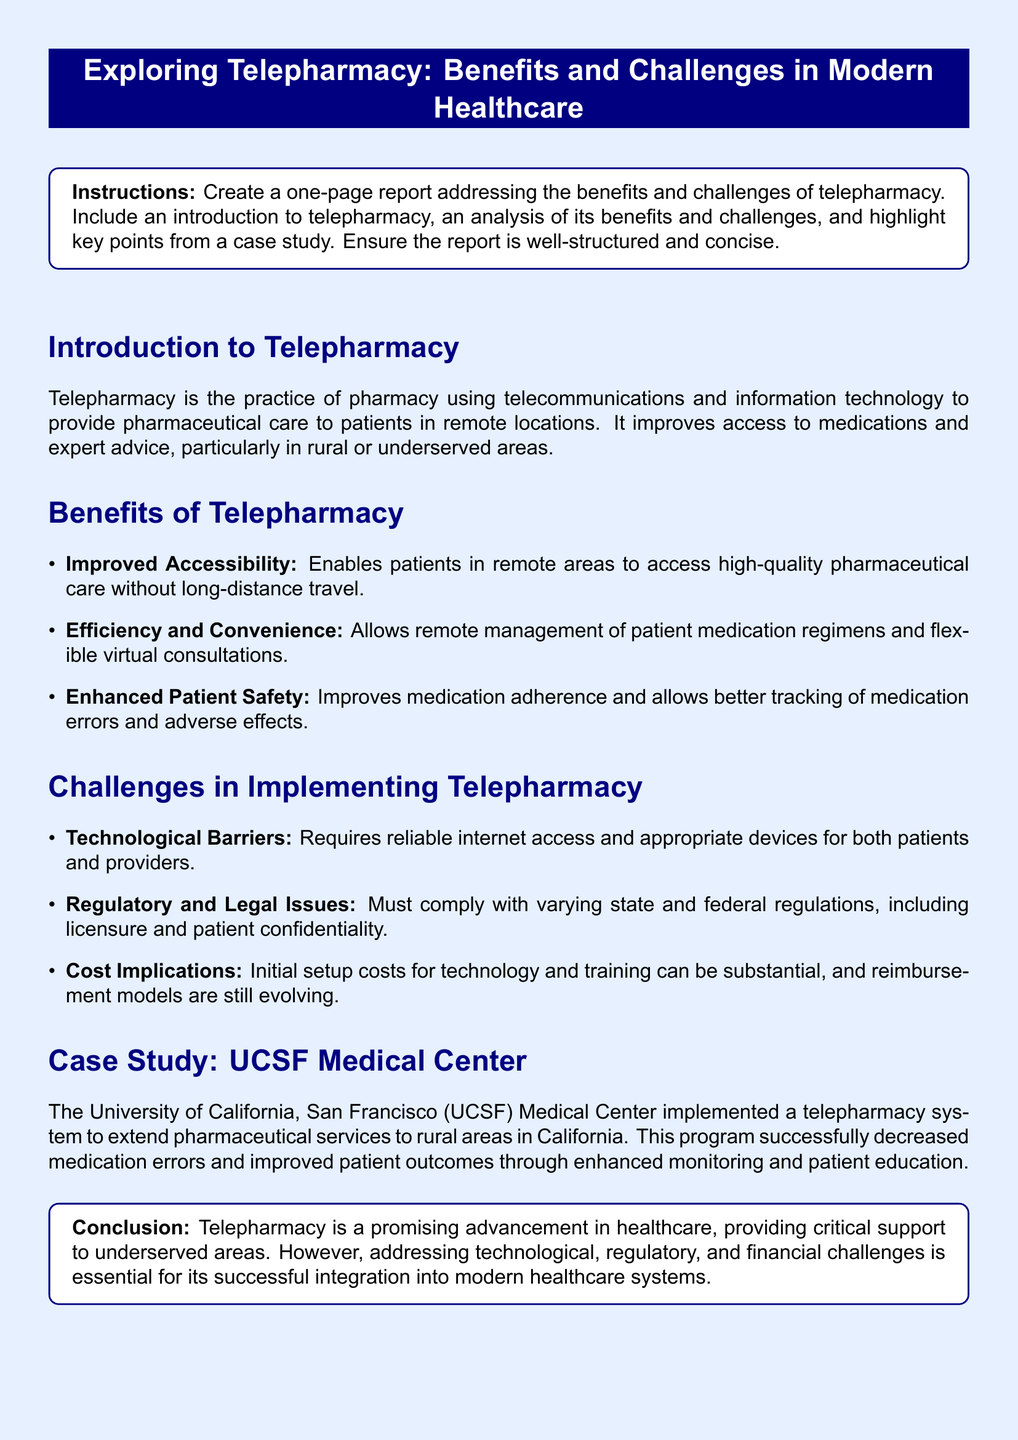What is telepharmacy? Telepharmacy is defined in the document as the practice of using telecommunications and information technology to provide pharmaceutical care to patients in remote locations.
Answer: the practice of pharmacy using telecommunications and information technology What is one benefit of telepharmacy? The document lists several benefits; one of them is improved accessibility for patients in remote areas.
Answer: improved accessibility What are the regulatory challenges mentioned? The document states that telepharmacy must comply with varying state and federal regulations, including licensure and patient confidentiality.
Answer: regulatory and legal issues Which case study is highlighted in the document? The document specifically refers to the UCSF Medical Center as a case study that implemented a telepharmacy system.
Answer: UCSF Medical Center What effect did the UCSF Medical Center's telepharmacy program have? According to the document, the program successfully decreased medication errors and improved patient outcomes.
Answer: decreased medication errors and improved patient outcomes What is one challenge mentioned related to technology? The document cites the need for reliable internet access and appropriate devices as a technological barrier.
Answer: technological barriers How are telepharmacy's initial costs described? The initial setup costs for technology and training are described as substantial in the document.
Answer: substantial What does the conclusion of the report emphasize? The conclusion emphasizes that addressing technological, regulatory, and financial challenges is essential for successful telepharmacy integration.
Answer: addressing technological, regulatory, and financial challenges What overall category does the document belong to? The document is structured as a report that explores a specific topic related to healthcare.
Answer: report 